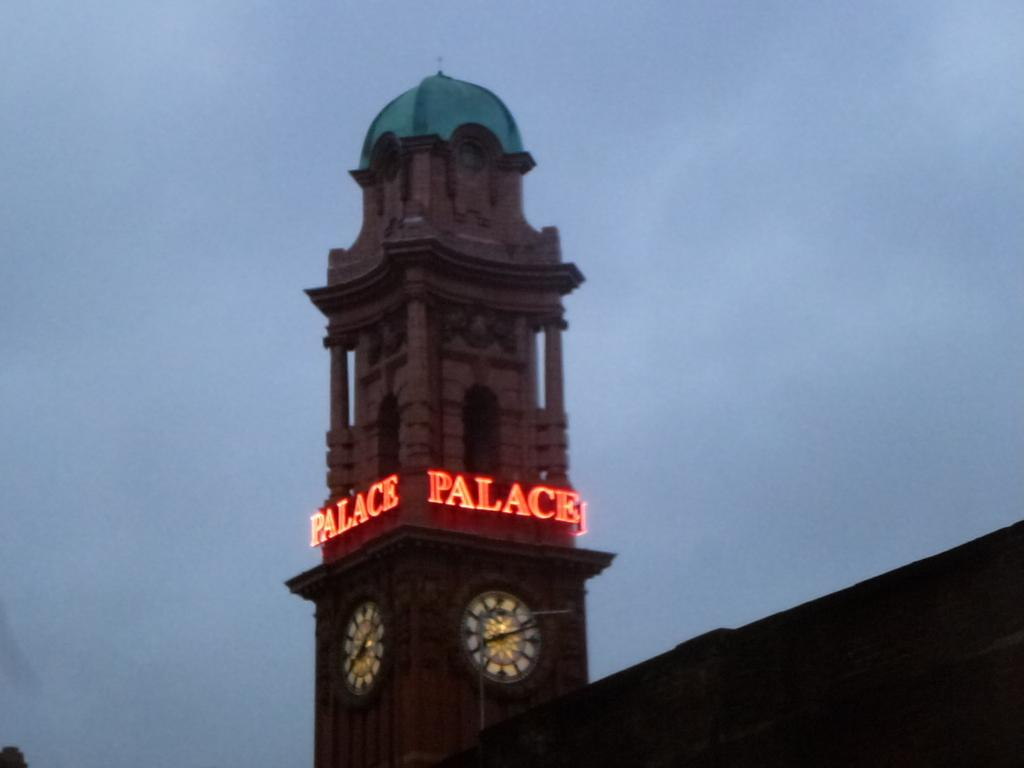<image>
Relay a brief, clear account of the picture shown. A clocktower on a building with Palace in neon. 